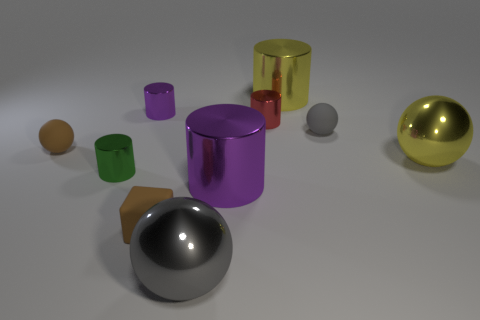What number of shiny things are both behind the block and in front of the yellow ball?
Offer a very short reply. 2. How many things are either small green rubber cylinders or metallic balls that are in front of the small brown block?
Your answer should be compact. 1. There is a small thing that is the same color as the block; what shape is it?
Offer a very short reply. Sphere. There is a matte thing on the left side of the small green cylinder; what color is it?
Offer a very short reply. Brown. How many things are either purple things that are right of the big gray metallic sphere or gray matte things?
Your answer should be compact. 2. There is another sphere that is the same size as the yellow shiny ball; what color is it?
Keep it short and to the point. Gray. Are there more yellow metallic cylinders that are in front of the tiny purple thing than metal things?
Your answer should be compact. No. There is a object that is both right of the red metallic cylinder and in front of the tiny brown rubber ball; what material is it made of?
Offer a terse response. Metal. There is a small matte thing that is to the left of the tiny block; is its color the same as the big ball in front of the tiny brown block?
Offer a very short reply. No. What number of other objects are there of the same size as the cube?
Your answer should be very brief. 5. 